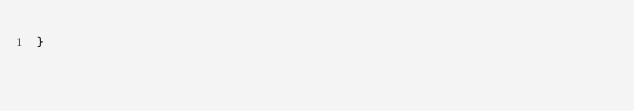<code> <loc_0><loc_0><loc_500><loc_500><_Java_>}
</code> 